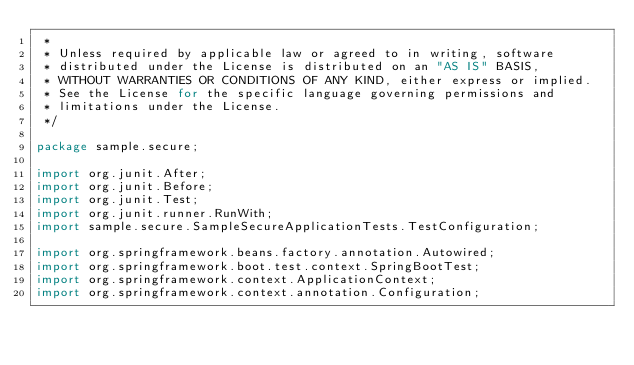<code> <loc_0><loc_0><loc_500><loc_500><_Java_> *
 * Unless required by applicable law or agreed to in writing, software
 * distributed under the License is distributed on an "AS IS" BASIS,
 * WITHOUT WARRANTIES OR CONDITIONS OF ANY KIND, either express or implied.
 * See the License for the specific language governing permissions and
 * limitations under the License.
 */

package sample.secure;

import org.junit.After;
import org.junit.Before;
import org.junit.Test;
import org.junit.runner.RunWith;
import sample.secure.SampleSecureApplicationTests.TestConfiguration;

import org.springframework.beans.factory.annotation.Autowired;
import org.springframework.boot.test.context.SpringBootTest;
import org.springframework.context.ApplicationContext;
import org.springframework.context.annotation.Configuration;</code> 